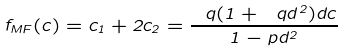<formula> <loc_0><loc_0><loc_500><loc_500>f _ { M F } ( c ) = c _ { 1 } + 2 c _ { 2 } = \frac { \ q ( 1 + \ q d ^ { 2 } ) d c } { 1 - p d ^ { 2 } }</formula> 